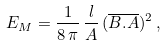<formula> <loc_0><loc_0><loc_500><loc_500>E _ { M } = \frac { 1 } { 8 \, \pi } \, \frac { l } { A } \, ( \overline { B . A } ) ^ { 2 } \, ,</formula> 